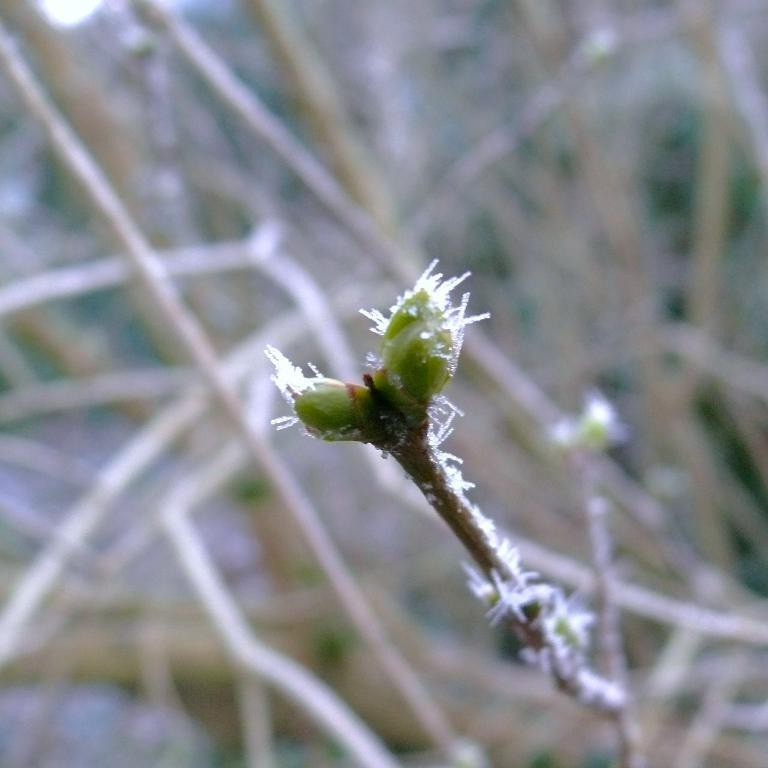What color is the object in the image? The object in the image is green. What else can be seen in the image besides the green object? There are sticks visible in the image. Can you describe the background of the image? The background of the image appears blurry. What type of rhythm can be heard coming from the green object in the image? There is no sound or rhythm associated with the green object in the image. 